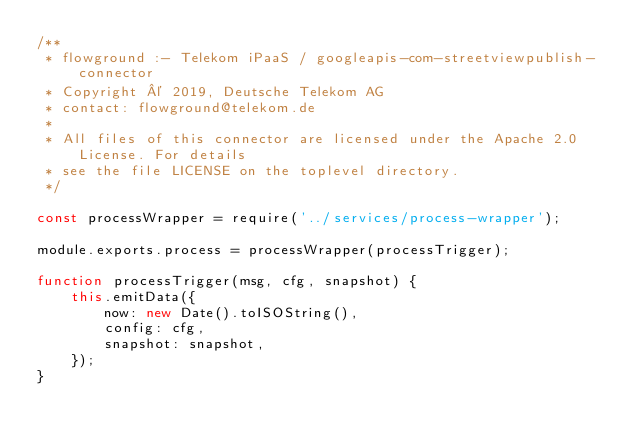Convert code to text. <code><loc_0><loc_0><loc_500><loc_500><_JavaScript_>/**
 * flowground :- Telekom iPaaS / googleapis-com-streetviewpublish-connector
 * Copyright © 2019, Deutsche Telekom AG
 * contact: flowground@telekom.de
 *
 * All files of this connector are licensed under the Apache 2.0 License. For details
 * see the file LICENSE on the toplevel directory.
 */

const processWrapper = require('../services/process-wrapper');

module.exports.process = processWrapper(processTrigger);

function processTrigger(msg, cfg, snapshot) {
    this.emitData({
        now: new Date().toISOString(),
        config: cfg,
        snapshot: snapshot,
    });
}</code> 